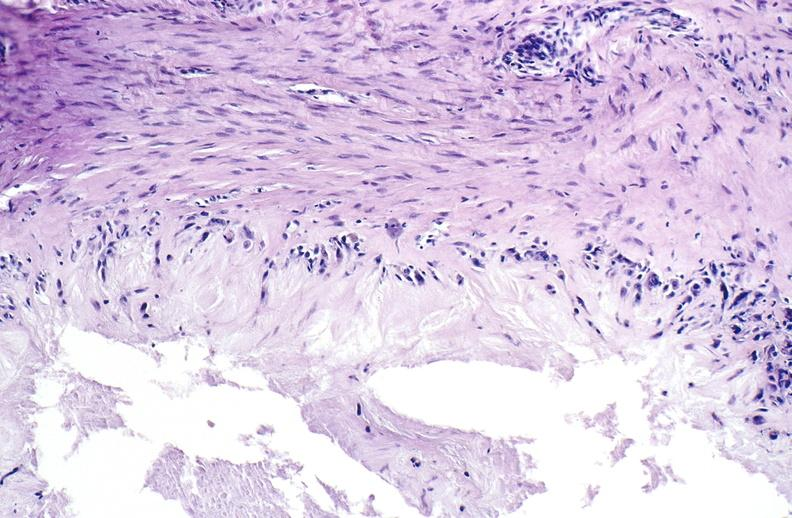s surface of nodes seen externally in slide present?
Answer the question using a single word or phrase. No 